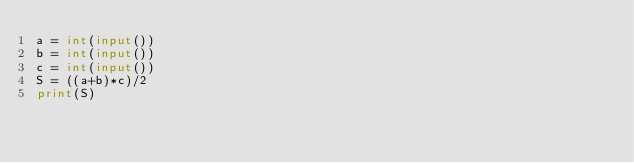Convert code to text. <code><loc_0><loc_0><loc_500><loc_500><_Python_>a = int(input())
b = int(input())
c = int(input())
S = ((a+b)*c)/2
print(S)</code> 